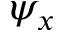Convert formula to latex. <formula><loc_0><loc_0><loc_500><loc_500>\psi _ { x }</formula> 